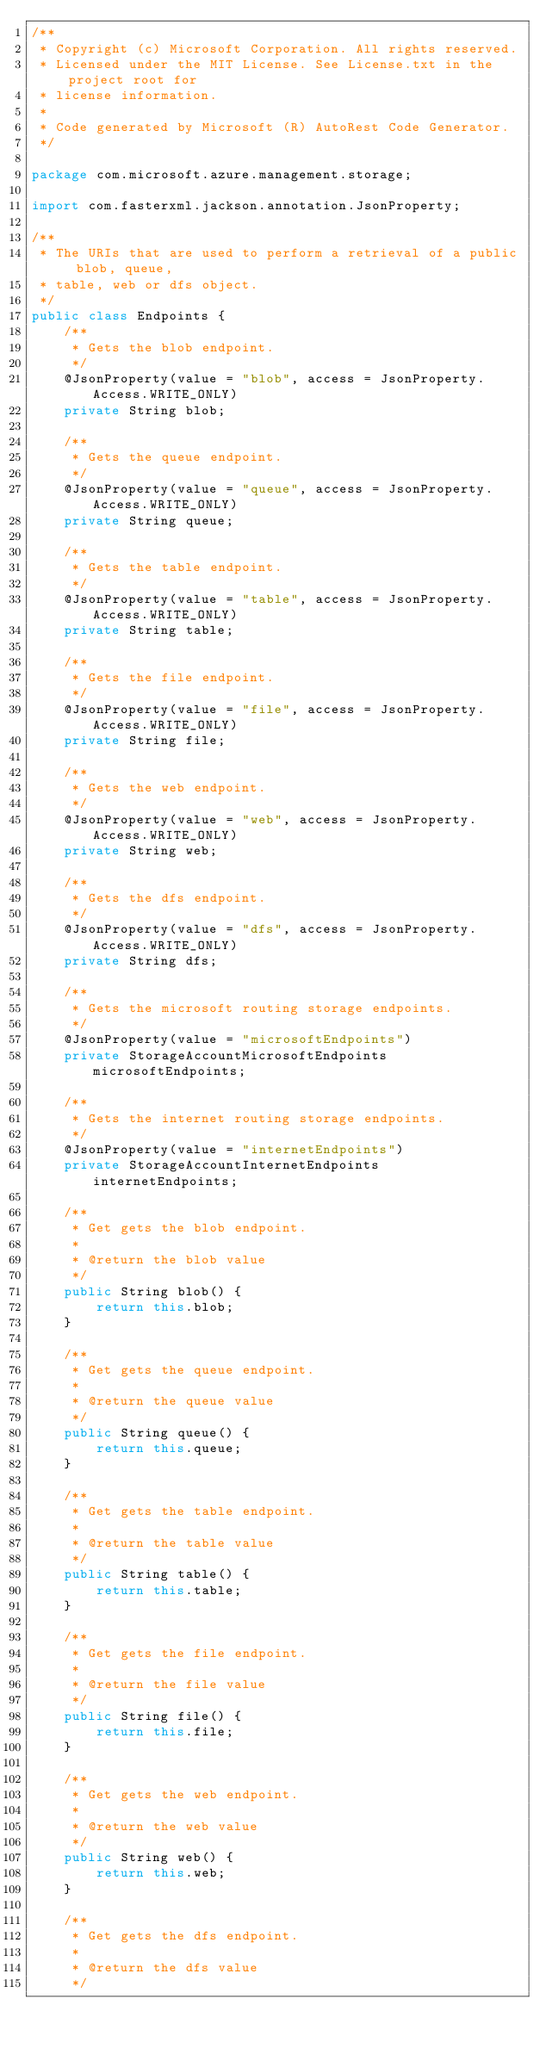Convert code to text. <code><loc_0><loc_0><loc_500><loc_500><_Java_>/**
 * Copyright (c) Microsoft Corporation. All rights reserved.
 * Licensed under the MIT License. See License.txt in the project root for
 * license information.
 *
 * Code generated by Microsoft (R) AutoRest Code Generator.
 */

package com.microsoft.azure.management.storage;

import com.fasterxml.jackson.annotation.JsonProperty;

/**
 * The URIs that are used to perform a retrieval of a public blob, queue,
 * table, web or dfs object.
 */
public class Endpoints {
    /**
     * Gets the blob endpoint.
     */
    @JsonProperty(value = "blob", access = JsonProperty.Access.WRITE_ONLY)
    private String blob;

    /**
     * Gets the queue endpoint.
     */
    @JsonProperty(value = "queue", access = JsonProperty.Access.WRITE_ONLY)
    private String queue;

    /**
     * Gets the table endpoint.
     */
    @JsonProperty(value = "table", access = JsonProperty.Access.WRITE_ONLY)
    private String table;

    /**
     * Gets the file endpoint.
     */
    @JsonProperty(value = "file", access = JsonProperty.Access.WRITE_ONLY)
    private String file;

    /**
     * Gets the web endpoint.
     */
    @JsonProperty(value = "web", access = JsonProperty.Access.WRITE_ONLY)
    private String web;

    /**
     * Gets the dfs endpoint.
     */
    @JsonProperty(value = "dfs", access = JsonProperty.Access.WRITE_ONLY)
    private String dfs;

    /**
     * Gets the microsoft routing storage endpoints.
     */
    @JsonProperty(value = "microsoftEndpoints")
    private StorageAccountMicrosoftEndpoints microsoftEndpoints;

    /**
     * Gets the internet routing storage endpoints.
     */
    @JsonProperty(value = "internetEndpoints")
    private StorageAccountInternetEndpoints internetEndpoints;

    /**
     * Get gets the blob endpoint.
     *
     * @return the blob value
     */
    public String blob() {
        return this.blob;
    }

    /**
     * Get gets the queue endpoint.
     *
     * @return the queue value
     */
    public String queue() {
        return this.queue;
    }

    /**
     * Get gets the table endpoint.
     *
     * @return the table value
     */
    public String table() {
        return this.table;
    }

    /**
     * Get gets the file endpoint.
     *
     * @return the file value
     */
    public String file() {
        return this.file;
    }

    /**
     * Get gets the web endpoint.
     *
     * @return the web value
     */
    public String web() {
        return this.web;
    }

    /**
     * Get gets the dfs endpoint.
     *
     * @return the dfs value
     */</code> 